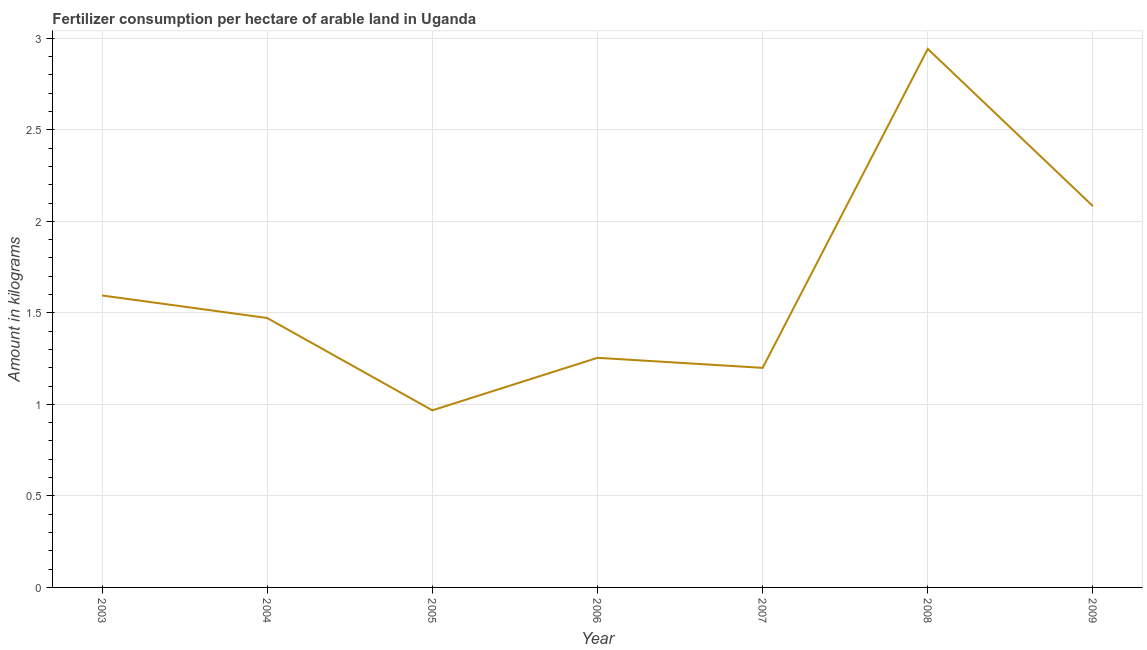What is the amount of fertilizer consumption in 2006?
Provide a succinct answer. 1.25. Across all years, what is the maximum amount of fertilizer consumption?
Provide a succinct answer. 2.94. Across all years, what is the minimum amount of fertilizer consumption?
Provide a short and direct response. 0.97. In which year was the amount of fertilizer consumption maximum?
Ensure brevity in your answer.  2008. In which year was the amount of fertilizer consumption minimum?
Give a very brief answer. 2005. What is the sum of the amount of fertilizer consumption?
Keep it short and to the point. 11.51. What is the difference between the amount of fertilizer consumption in 2003 and 2004?
Provide a short and direct response. 0.12. What is the average amount of fertilizer consumption per year?
Keep it short and to the point. 1.64. What is the median amount of fertilizer consumption?
Give a very brief answer. 1.47. What is the ratio of the amount of fertilizer consumption in 2004 to that in 2006?
Your response must be concise. 1.17. Is the amount of fertilizer consumption in 2004 less than that in 2006?
Your answer should be very brief. No. What is the difference between the highest and the second highest amount of fertilizer consumption?
Your response must be concise. 0.86. Is the sum of the amount of fertilizer consumption in 2004 and 2008 greater than the maximum amount of fertilizer consumption across all years?
Provide a succinct answer. Yes. What is the difference between the highest and the lowest amount of fertilizer consumption?
Give a very brief answer. 1.97. How many lines are there?
Your response must be concise. 1. What is the difference between two consecutive major ticks on the Y-axis?
Offer a very short reply. 0.5. What is the title of the graph?
Your answer should be very brief. Fertilizer consumption per hectare of arable land in Uganda . What is the label or title of the X-axis?
Ensure brevity in your answer.  Year. What is the label or title of the Y-axis?
Ensure brevity in your answer.  Amount in kilograms. What is the Amount in kilograms of 2003?
Keep it short and to the point. 1.6. What is the Amount in kilograms of 2004?
Your answer should be compact. 1.47. What is the Amount in kilograms of 2005?
Offer a very short reply. 0.97. What is the Amount in kilograms of 2006?
Your answer should be very brief. 1.25. What is the Amount in kilograms in 2007?
Provide a succinct answer. 1.2. What is the Amount in kilograms of 2008?
Your response must be concise. 2.94. What is the Amount in kilograms of 2009?
Keep it short and to the point. 2.08. What is the difference between the Amount in kilograms in 2003 and 2004?
Offer a terse response. 0.12. What is the difference between the Amount in kilograms in 2003 and 2005?
Give a very brief answer. 0.63. What is the difference between the Amount in kilograms in 2003 and 2006?
Provide a short and direct response. 0.34. What is the difference between the Amount in kilograms in 2003 and 2007?
Give a very brief answer. 0.4. What is the difference between the Amount in kilograms in 2003 and 2008?
Provide a short and direct response. -1.35. What is the difference between the Amount in kilograms in 2003 and 2009?
Give a very brief answer. -0.49. What is the difference between the Amount in kilograms in 2004 and 2005?
Your response must be concise. 0.5. What is the difference between the Amount in kilograms in 2004 and 2006?
Ensure brevity in your answer.  0.22. What is the difference between the Amount in kilograms in 2004 and 2007?
Your answer should be very brief. 0.27. What is the difference between the Amount in kilograms in 2004 and 2008?
Provide a short and direct response. -1.47. What is the difference between the Amount in kilograms in 2004 and 2009?
Ensure brevity in your answer.  -0.61. What is the difference between the Amount in kilograms in 2005 and 2006?
Offer a very short reply. -0.29. What is the difference between the Amount in kilograms in 2005 and 2007?
Offer a terse response. -0.23. What is the difference between the Amount in kilograms in 2005 and 2008?
Ensure brevity in your answer.  -1.97. What is the difference between the Amount in kilograms in 2005 and 2009?
Ensure brevity in your answer.  -1.12. What is the difference between the Amount in kilograms in 2006 and 2007?
Your answer should be compact. 0.05. What is the difference between the Amount in kilograms in 2006 and 2008?
Keep it short and to the point. -1.69. What is the difference between the Amount in kilograms in 2006 and 2009?
Your answer should be very brief. -0.83. What is the difference between the Amount in kilograms in 2007 and 2008?
Provide a succinct answer. -1.74. What is the difference between the Amount in kilograms in 2007 and 2009?
Provide a short and direct response. -0.88. What is the difference between the Amount in kilograms in 2008 and 2009?
Make the answer very short. 0.86. What is the ratio of the Amount in kilograms in 2003 to that in 2004?
Your answer should be compact. 1.08. What is the ratio of the Amount in kilograms in 2003 to that in 2005?
Offer a terse response. 1.65. What is the ratio of the Amount in kilograms in 2003 to that in 2006?
Ensure brevity in your answer.  1.27. What is the ratio of the Amount in kilograms in 2003 to that in 2007?
Keep it short and to the point. 1.33. What is the ratio of the Amount in kilograms in 2003 to that in 2008?
Give a very brief answer. 0.54. What is the ratio of the Amount in kilograms in 2003 to that in 2009?
Your answer should be compact. 0.77. What is the ratio of the Amount in kilograms in 2004 to that in 2005?
Ensure brevity in your answer.  1.52. What is the ratio of the Amount in kilograms in 2004 to that in 2006?
Ensure brevity in your answer.  1.17. What is the ratio of the Amount in kilograms in 2004 to that in 2007?
Offer a very short reply. 1.23. What is the ratio of the Amount in kilograms in 2004 to that in 2008?
Your answer should be very brief. 0.5. What is the ratio of the Amount in kilograms in 2004 to that in 2009?
Give a very brief answer. 0.71. What is the ratio of the Amount in kilograms in 2005 to that in 2006?
Your answer should be very brief. 0.77. What is the ratio of the Amount in kilograms in 2005 to that in 2007?
Offer a very short reply. 0.81. What is the ratio of the Amount in kilograms in 2005 to that in 2008?
Offer a terse response. 0.33. What is the ratio of the Amount in kilograms in 2005 to that in 2009?
Offer a terse response. 0.46. What is the ratio of the Amount in kilograms in 2006 to that in 2007?
Keep it short and to the point. 1.05. What is the ratio of the Amount in kilograms in 2006 to that in 2008?
Your answer should be very brief. 0.43. What is the ratio of the Amount in kilograms in 2006 to that in 2009?
Your answer should be compact. 0.6. What is the ratio of the Amount in kilograms in 2007 to that in 2008?
Provide a succinct answer. 0.41. What is the ratio of the Amount in kilograms in 2007 to that in 2009?
Provide a short and direct response. 0.58. What is the ratio of the Amount in kilograms in 2008 to that in 2009?
Offer a very short reply. 1.41. 